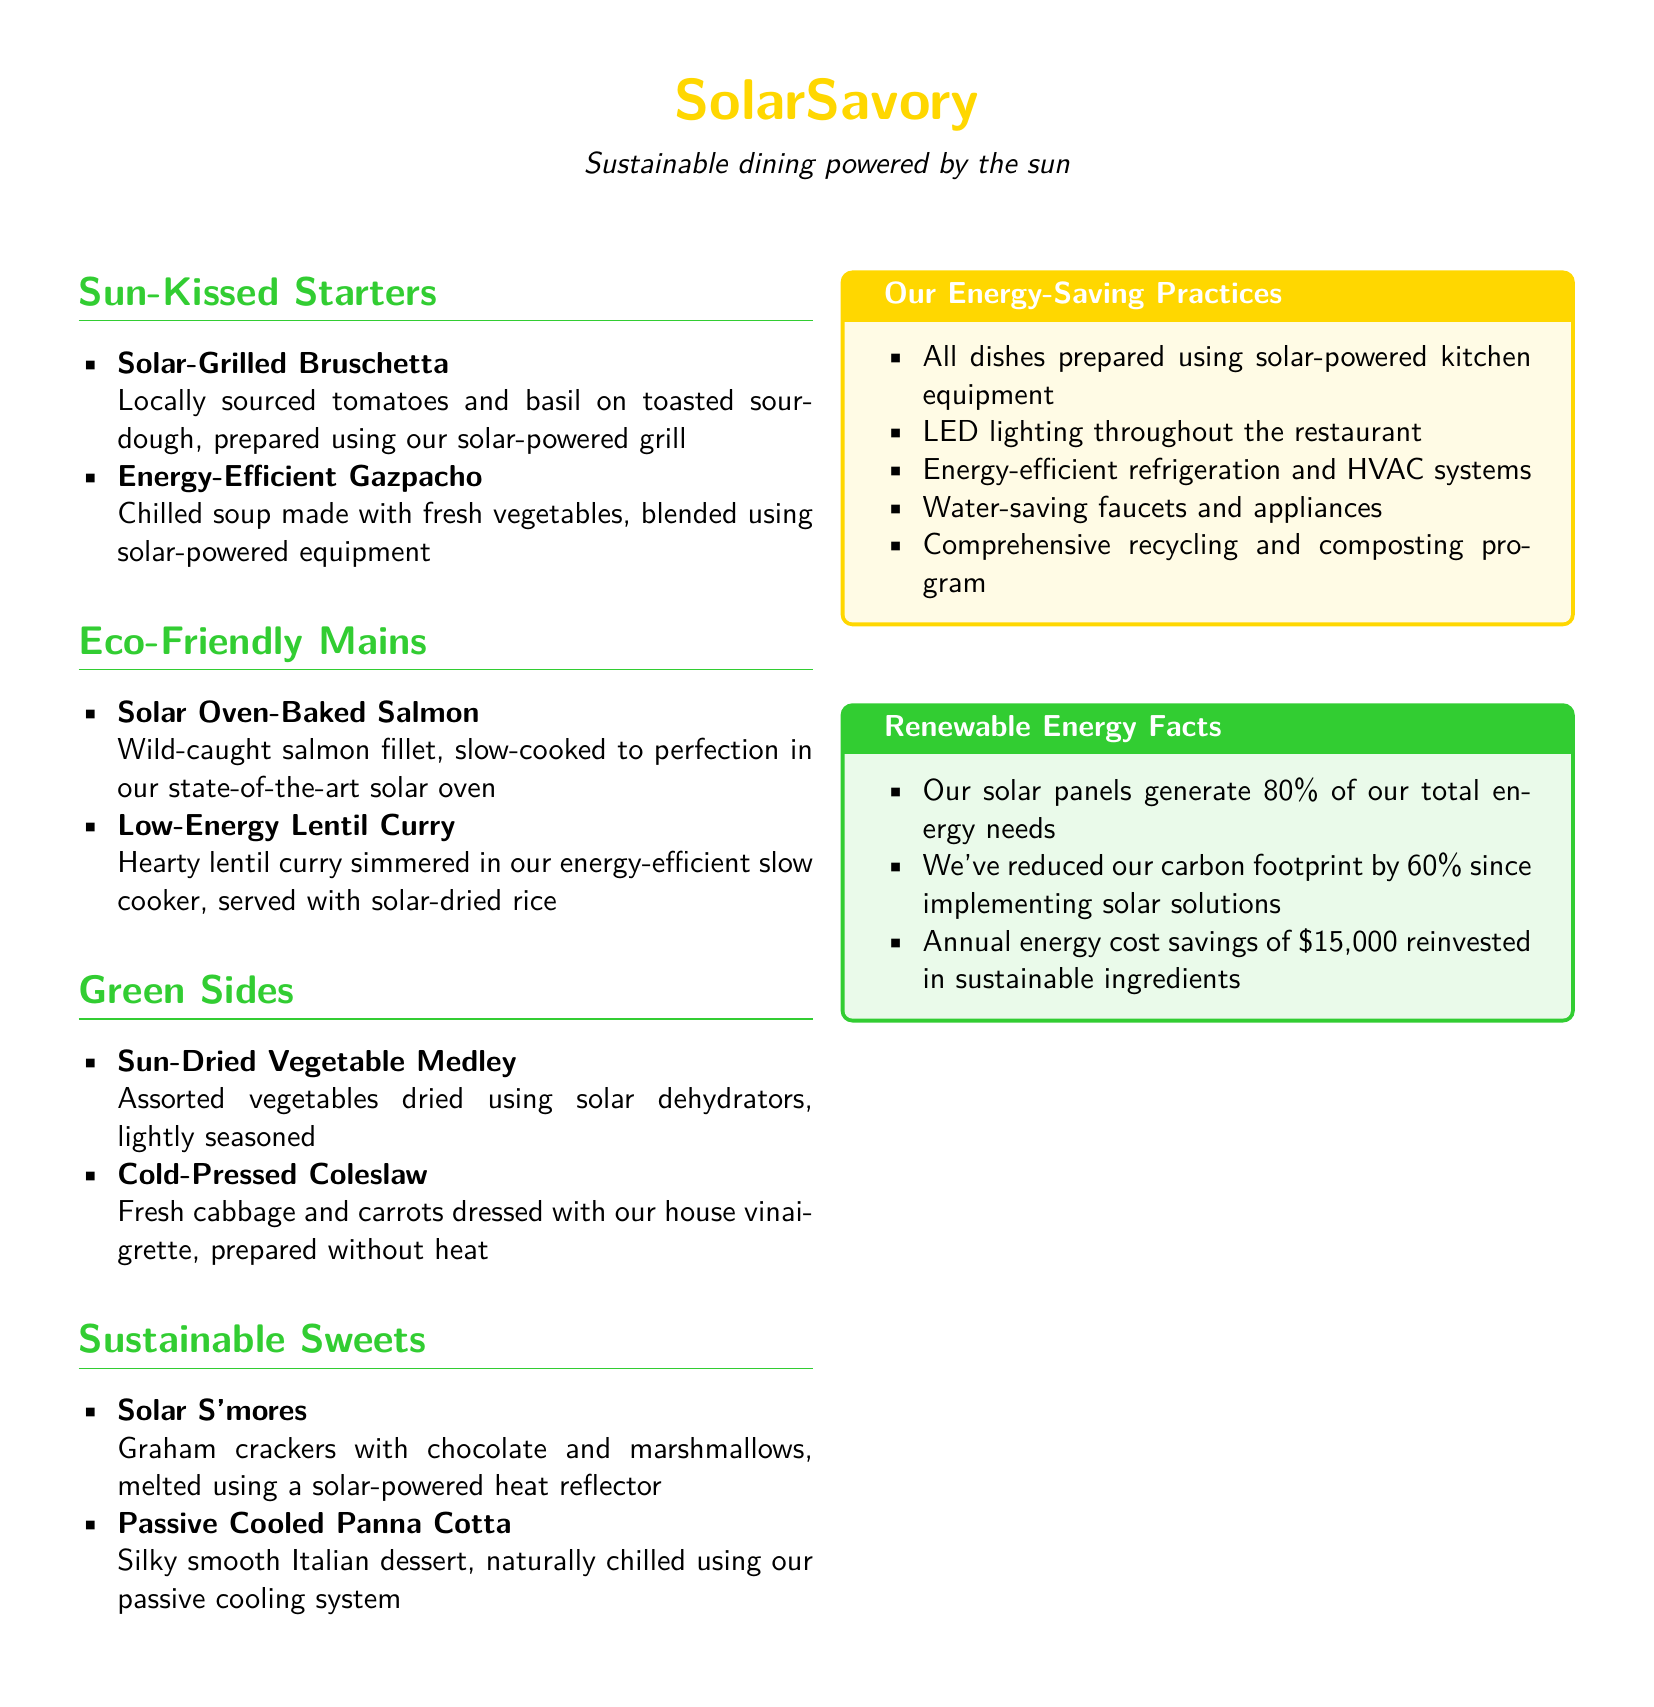What is the restaurant's name? The name "SolarSavory" appears prominently at the top of the menu.
Answer: SolarSavory What is the overarching theme of the restaurant? The menu states that it provides "Sustainable dining powered by the sun".
Answer: Sustainable dining powered by the sun What type of equipment is used to prepare the dishes? The menu mentions that all dishes are prepared using solar-powered kitchen equipment.
Answer: Solar-powered kitchen equipment What dish is made with wild-caught salmon? The dish "Solar Oven-Baked Salmon" includes wild-caught salmon fillet.
Answer: Solar Oven-Baked Salmon What percentage of the restaurant's total energy needs is supplied by solar panels? The menu indicates that solar panels generate 80% of the restaurant's total energy needs.
Answer: 80% How much has the restaurant reduced its carbon footprint? The document states that the carbon footprint has been reduced by 60% since implementing solar solutions.
Answer: 60% Which dessert is prepared using a solar-powered heat reflector? The dessert "Solar S'mores" is made by melting ingredients using a solar-powered heat reflector.
Answer: Solar S'mores What is one of the energy-saving practices mentioned? The menu lists multiple energy-saving practices; one example is "LED lighting throughout the restaurant".
Answer: LED lighting throughout the restaurant How much annual energy cost savings does the restaurant have? The document specifies that annual energy cost savings amount to $15,000.
Answer: $15,000 